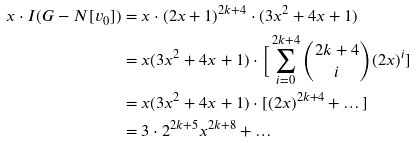Convert formula to latex. <formula><loc_0><loc_0><loc_500><loc_500>x \cdot I ( G - N [ v _ { 0 } ] ) & = x \cdot ( 2 x + 1 ) ^ { 2 k + 4 } \cdot ( 3 x ^ { 2 } + 4 x + 1 ) \\ & = x ( 3 x ^ { 2 } + 4 x + 1 ) \cdot \Big [ \sum _ { i = 0 } ^ { 2 k + 4 } \binom { 2 k + 4 } { i } ( 2 x ) ^ { i } ] \\ & = x ( 3 x ^ { 2 } + 4 x + 1 ) \cdot [ ( 2 x ) ^ { 2 k + 4 } + \dots ] \\ & = 3 \cdot 2 ^ { 2 k + 5 } x ^ { 2 k + 8 } + \dots</formula> 